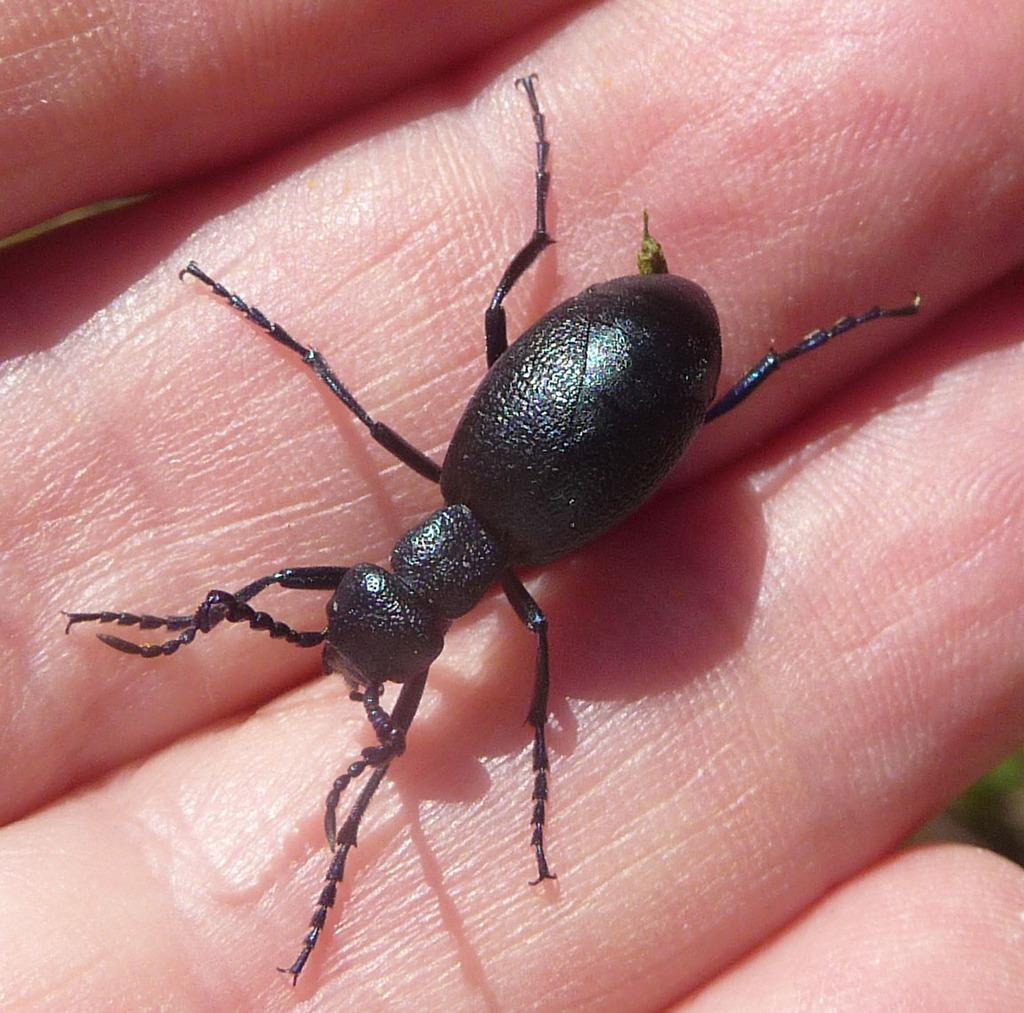What type of creature can be seen in the image? There is an insect in the image. Where is the insect located in the image? The insect is on the fingers of a person. What type of gardening tool is being used by the insect in the image? There is no gardening tool present in the image, as it features an insect on the fingers of a person. 